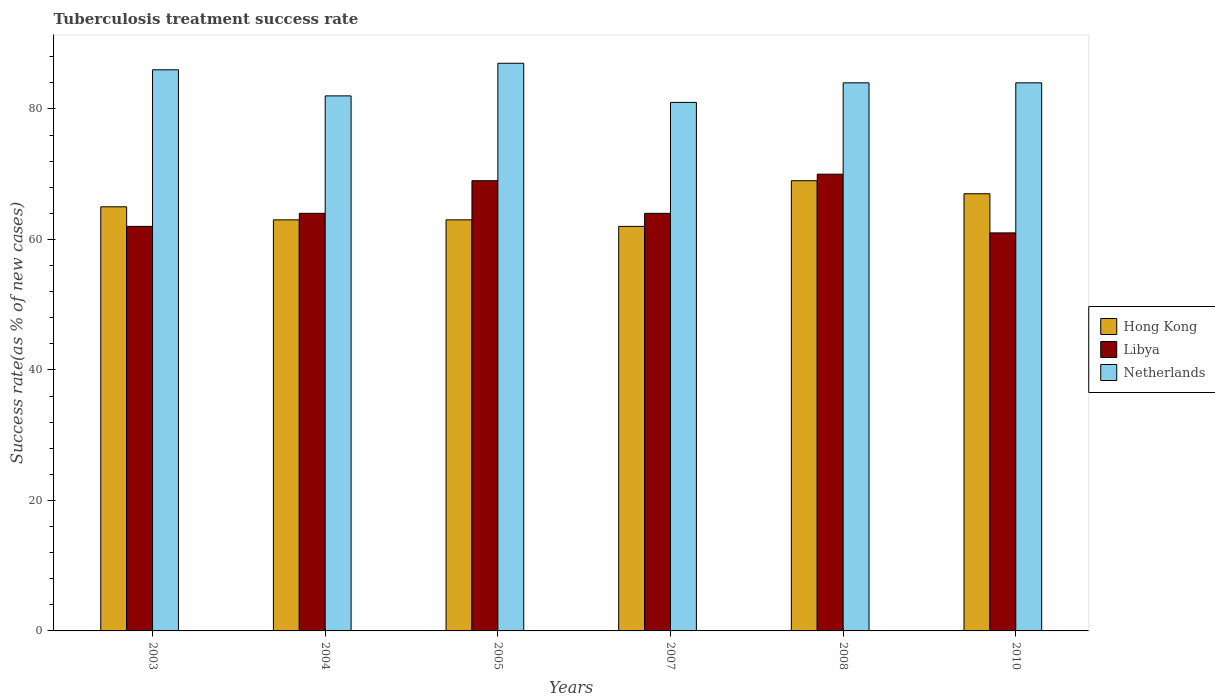How many different coloured bars are there?
Your response must be concise. 3. Are the number of bars on each tick of the X-axis equal?
Ensure brevity in your answer.  Yes. How many bars are there on the 4th tick from the left?
Offer a very short reply. 3. How many bars are there on the 3rd tick from the right?
Make the answer very short. 3. In how many cases, is the number of bars for a given year not equal to the number of legend labels?
Give a very brief answer. 0. Across all years, what is the minimum tuberculosis treatment success rate in Hong Kong?
Your answer should be very brief. 62. In which year was the tuberculosis treatment success rate in Hong Kong maximum?
Ensure brevity in your answer.  2008. In which year was the tuberculosis treatment success rate in Hong Kong minimum?
Offer a terse response. 2007. What is the total tuberculosis treatment success rate in Netherlands in the graph?
Your answer should be very brief. 504. What is the difference between the tuberculosis treatment success rate in Libya in 2005 and that in 2010?
Ensure brevity in your answer.  8. What is the average tuberculosis treatment success rate in Libya per year?
Offer a very short reply. 65. In the year 2008, what is the difference between the tuberculosis treatment success rate in Hong Kong and tuberculosis treatment success rate in Libya?
Ensure brevity in your answer.  -1. What is the ratio of the tuberculosis treatment success rate in Hong Kong in 2003 to that in 2007?
Keep it short and to the point. 1.05. Is the difference between the tuberculosis treatment success rate in Hong Kong in 2003 and 2004 greater than the difference between the tuberculosis treatment success rate in Libya in 2003 and 2004?
Ensure brevity in your answer.  Yes. What is the difference between the highest and the lowest tuberculosis treatment success rate in Hong Kong?
Provide a succinct answer. 7. Is the sum of the tuberculosis treatment success rate in Libya in 2003 and 2005 greater than the maximum tuberculosis treatment success rate in Netherlands across all years?
Provide a short and direct response. Yes. What does the 3rd bar from the left in 2007 represents?
Keep it short and to the point. Netherlands. What does the 1st bar from the right in 2007 represents?
Provide a succinct answer. Netherlands. Is it the case that in every year, the sum of the tuberculosis treatment success rate in Hong Kong and tuberculosis treatment success rate in Netherlands is greater than the tuberculosis treatment success rate in Libya?
Keep it short and to the point. Yes. Does the graph contain any zero values?
Provide a succinct answer. No. Does the graph contain grids?
Your response must be concise. No. What is the title of the graph?
Your answer should be very brief. Tuberculosis treatment success rate. Does "Oman" appear as one of the legend labels in the graph?
Offer a terse response. No. What is the label or title of the Y-axis?
Give a very brief answer. Success rate(as % of new cases). What is the Success rate(as % of new cases) of Hong Kong in 2003?
Give a very brief answer. 65. What is the Success rate(as % of new cases) of Netherlands in 2003?
Provide a succinct answer. 86. What is the Success rate(as % of new cases) in Hong Kong in 2004?
Give a very brief answer. 63. What is the Success rate(as % of new cases) in Hong Kong in 2005?
Your answer should be compact. 63. What is the Success rate(as % of new cases) of Libya in 2005?
Make the answer very short. 69. What is the Success rate(as % of new cases) in Netherlands in 2005?
Offer a terse response. 87. What is the Success rate(as % of new cases) of Hong Kong in 2007?
Your answer should be compact. 62. What is the Success rate(as % of new cases) of Netherlands in 2007?
Offer a very short reply. 81. What is the Success rate(as % of new cases) of Hong Kong in 2008?
Keep it short and to the point. 69. What is the Success rate(as % of new cases) of Libya in 2008?
Your answer should be compact. 70. What is the Success rate(as % of new cases) in Netherlands in 2008?
Ensure brevity in your answer.  84. What is the Success rate(as % of new cases) in Hong Kong in 2010?
Provide a succinct answer. 67. What is the Success rate(as % of new cases) of Libya in 2010?
Provide a succinct answer. 61. Across all years, what is the maximum Success rate(as % of new cases) in Hong Kong?
Provide a succinct answer. 69. Across all years, what is the minimum Success rate(as % of new cases) in Libya?
Your response must be concise. 61. What is the total Success rate(as % of new cases) of Hong Kong in the graph?
Keep it short and to the point. 389. What is the total Success rate(as % of new cases) in Libya in the graph?
Give a very brief answer. 390. What is the total Success rate(as % of new cases) in Netherlands in the graph?
Your answer should be compact. 504. What is the difference between the Success rate(as % of new cases) of Hong Kong in 2003 and that in 2004?
Provide a succinct answer. 2. What is the difference between the Success rate(as % of new cases) of Hong Kong in 2003 and that in 2007?
Your response must be concise. 3. What is the difference between the Success rate(as % of new cases) of Netherlands in 2003 and that in 2007?
Provide a short and direct response. 5. What is the difference between the Success rate(as % of new cases) in Hong Kong in 2003 and that in 2008?
Offer a very short reply. -4. What is the difference between the Success rate(as % of new cases) of Netherlands in 2003 and that in 2008?
Your answer should be very brief. 2. What is the difference between the Success rate(as % of new cases) of Libya in 2003 and that in 2010?
Offer a terse response. 1. What is the difference between the Success rate(as % of new cases) of Libya in 2004 and that in 2005?
Offer a terse response. -5. What is the difference between the Success rate(as % of new cases) of Libya in 2004 and that in 2007?
Your answer should be compact. 0. What is the difference between the Success rate(as % of new cases) of Netherlands in 2004 and that in 2007?
Provide a short and direct response. 1. What is the difference between the Success rate(as % of new cases) of Hong Kong in 2004 and that in 2008?
Your answer should be very brief. -6. What is the difference between the Success rate(as % of new cases) of Libya in 2004 and that in 2008?
Provide a succinct answer. -6. What is the difference between the Success rate(as % of new cases) in Netherlands in 2004 and that in 2008?
Provide a short and direct response. -2. What is the difference between the Success rate(as % of new cases) of Hong Kong in 2004 and that in 2010?
Provide a short and direct response. -4. What is the difference between the Success rate(as % of new cases) of Libya in 2004 and that in 2010?
Your answer should be very brief. 3. What is the difference between the Success rate(as % of new cases) of Libya in 2005 and that in 2007?
Provide a succinct answer. 5. What is the difference between the Success rate(as % of new cases) of Libya in 2005 and that in 2008?
Provide a short and direct response. -1. What is the difference between the Success rate(as % of new cases) of Libya in 2005 and that in 2010?
Give a very brief answer. 8. What is the difference between the Success rate(as % of new cases) in Netherlands in 2005 and that in 2010?
Keep it short and to the point. 3. What is the difference between the Success rate(as % of new cases) of Hong Kong in 2007 and that in 2008?
Offer a very short reply. -7. What is the difference between the Success rate(as % of new cases) of Libya in 2007 and that in 2008?
Keep it short and to the point. -6. What is the difference between the Success rate(as % of new cases) in Hong Kong in 2007 and that in 2010?
Make the answer very short. -5. What is the difference between the Success rate(as % of new cases) of Netherlands in 2007 and that in 2010?
Offer a very short reply. -3. What is the difference between the Success rate(as % of new cases) of Hong Kong in 2008 and that in 2010?
Offer a terse response. 2. What is the difference between the Success rate(as % of new cases) of Libya in 2008 and that in 2010?
Provide a succinct answer. 9. What is the difference between the Success rate(as % of new cases) in Hong Kong in 2003 and the Success rate(as % of new cases) in Libya in 2004?
Keep it short and to the point. 1. What is the difference between the Success rate(as % of new cases) of Libya in 2003 and the Success rate(as % of new cases) of Netherlands in 2004?
Ensure brevity in your answer.  -20. What is the difference between the Success rate(as % of new cases) in Hong Kong in 2003 and the Success rate(as % of new cases) in Libya in 2005?
Your answer should be very brief. -4. What is the difference between the Success rate(as % of new cases) in Hong Kong in 2003 and the Success rate(as % of new cases) in Netherlands in 2005?
Offer a very short reply. -22. What is the difference between the Success rate(as % of new cases) of Libya in 2003 and the Success rate(as % of new cases) of Netherlands in 2007?
Your answer should be compact. -19. What is the difference between the Success rate(as % of new cases) of Hong Kong in 2003 and the Success rate(as % of new cases) of Libya in 2008?
Provide a succinct answer. -5. What is the difference between the Success rate(as % of new cases) in Hong Kong in 2003 and the Success rate(as % of new cases) in Netherlands in 2008?
Your answer should be very brief. -19. What is the difference between the Success rate(as % of new cases) in Hong Kong in 2003 and the Success rate(as % of new cases) in Netherlands in 2010?
Keep it short and to the point. -19. What is the difference between the Success rate(as % of new cases) in Libya in 2004 and the Success rate(as % of new cases) in Netherlands in 2005?
Provide a short and direct response. -23. What is the difference between the Success rate(as % of new cases) in Libya in 2004 and the Success rate(as % of new cases) in Netherlands in 2007?
Provide a succinct answer. -17. What is the difference between the Success rate(as % of new cases) in Hong Kong in 2004 and the Success rate(as % of new cases) in Libya in 2008?
Offer a very short reply. -7. What is the difference between the Success rate(as % of new cases) of Hong Kong in 2004 and the Success rate(as % of new cases) of Netherlands in 2008?
Your answer should be compact. -21. What is the difference between the Success rate(as % of new cases) of Libya in 2004 and the Success rate(as % of new cases) of Netherlands in 2010?
Give a very brief answer. -20. What is the difference between the Success rate(as % of new cases) in Hong Kong in 2005 and the Success rate(as % of new cases) in Libya in 2007?
Make the answer very short. -1. What is the difference between the Success rate(as % of new cases) of Hong Kong in 2005 and the Success rate(as % of new cases) of Netherlands in 2007?
Make the answer very short. -18. What is the difference between the Success rate(as % of new cases) in Libya in 2005 and the Success rate(as % of new cases) in Netherlands in 2007?
Provide a succinct answer. -12. What is the difference between the Success rate(as % of new cases) in Hong Kong in 2005 and the Success rate(as % of new cases) in Libya in 2010?
Your response must be concise. 2. What is the difference between the Success rate(as % of new cases) of Hong Kong in 2005 and the Success rate(as % of new cases) of Netherlands in 2010?
Your response must be concise. -21. What is the difference between the Success rate(as % of new cases) in Libya in 2005 and the Success rate(as % of new cases) in Netherlands in 2010?
Your answer should be very brief. -15. What is the difference between the Success rate(as % of new cases) in Hong Kong in 2007 and the Success rate(as % of new cases) in Netherlands in 2008?
Provide a succinct answer. -22. What is the difference between the Success rate(as % of new cases) of Hong Kong in 2007 and the Success rate(as % of new cases) of Libya in 2010?
Your response must be concise. 1. What is the difference between the Success rate(as % of new cases) in Libya in 2007 and the Success rate(as % of new cases) in Netherlands in 2010?
Ensure brevity in your answer.  -20. What is the difference between the Success rate(as % of new cases) of Hong Kong in 2008 and the Success rate(as % of new cases) of Netherlands in 2010?
Make the answer very short. -15. What is the average Success rate(as % of new cases) of Hong Kong per year?
Your answer should be very brief. 64.83. What is the average Success rate(as % of new cases) of Libya per year?
Give a very brief answer. 65. In the year 2003, what is the difference between the Success rate(as % of new cases) in Hong Kong and Success rate(as % of new cases) in Libya?
Provide a succinct answer. 3. In the year 2003, what is the difference between the Success rate(as % of new cases) of Hong Kong and Success rate(as % of new cases) of Netherlands?
Your answer should be very brief. -21. In the year 2003, what is the difference between the Success rate(as % of new cases) of Libya and Success rate(as % of new cases) of Netherlands?
Make the answer very short. -24. In the year 2004, what is the difference between the Success rate(as % of new cases) in Hong Kong and Success rate(as % of new cases) in Netherlands?
Give a very brief answer. -19. In the year 2004, what is the difference between the Success rate(as % of new cases) in Libya and Success rate(as % of new cases) in Netherlands?
Make the answer very short. -18. In the year 2005, what is the difference between the Success rate(as % of new cases) of Hong Kong and Success rate(as % of new cases) of Libya?
Provide a short and direct response. -6. In the year 2007, what is the difference between the Success rate(as % of new cases) of Hong Kong and Success rate(as % of new cases) of Netherlands?
Provide a short and direct response. -19. In the year 2008, what is the difference between the Success rate(as % of new cases) in Hong Kong and Success rate(as % of new cases) in Netherlands?
Offer a terse response. -15. In the year 2010, what is the difference between the Success rate(as % of new cases) of Libya and Success rate(as % of new cases) of Netherlands?
Make the answer very short. -23. What is the ratio of the Success rate(as % of new cases) of Hong Kong in 2003 to that in 2004?
Make the answer very short. 1.03. What is the ratio of the Success rate(as % of new cases) of Libya in 2003 to that in 2004?
Offer a terse response. 0.97. What is the ratio of the Success rate(as % of new cases) of Netherlands in 2003 to that in 2004?
Your answer should be very brief. 1.05. What is the ratio of the Success rate(as % of new cases) in Hong Kong in 2003 to that in 2005?
Give a very brief answer. 1.03. What is the ratio of the Success rate(as % of new cases) of Libya in 2003 to that in 2005?
Ensure brevity in your answer.  0.9. What is the ratio of the Success rate(as % of new cases) in Hong Kong in 2003 to that in 2007?
Keep it short and to the point. 1.05. What is the ratio of the Success rate(as % of new cases) in Libya in 2003 to that in 2007?
Make the answer very short. 0.97. What is the ratio of the Success rate(as % of new cases) of Netherlands in 2003 to that in 2007?
Ensure brevity in your answer.  1.06. What is the ratio of the Success rate(as % of new cases) in Hong Kong in 2003 to that in 2008?
Ensure brevity in your answer.  0.94. What is the ratio of the Success rate(as % of new cases) of Libya in 2003 to that in 2008?
Ensure brevity in your answer.  0.89. What is the ratio of the Success rate(as % of new cases) in Netherlands in 2003 to that in 2008?
Give a very brief answer. 1.02. What is the ratio of the Success rate(as % of new cases) in Hong Kong in 2003 to that in 2010?
Provide a short and direct response. 0.97. What is the ratio of the Success rate(as % of new cases) in Libya in 2003 to that in 2010?
Your answer should be very brief. 1.02. What is the ratio of the Success rate(as % of new cases) of Netherlands in 2003 to that in 2010?
Offer a terse response. 1.02. What is the ratio of the Success rate(as % of new cases) of Libya in 2004 to that in 2005?
Offer a terse response. 0.93. What is the ratio of the Success rate(as % of new cases) in Netherlands in 2004 to that in 2005?
Give a very brief answer. 0.94. What is the ratio of the Success rate(as % of new cases) in Hong Kong in 2004 to that in 2007?
Give a very brief answer. 1.02. What is the ratio of the Success rate(as % of new cases) in Libya in 2004 to that in 2007?
Provide a succinct answer. 1. What is the ratio of the Success rate(as % of new cases) in Netherlands in 2004 to that in 2007?
Your response must be concise. 1.01. What is the ratio of the Success rate(as % of new cases) of Hong Kong in 2004 to that in 2008?
Provide a short and direct response. 0.91. What is the ratio of the Success rate(as % of new cases) of Libya in 2004 to that in 2008?
Offer a terse response. 0.91. What is the ratio of the Success rate(as % of new cases) of Netherlands in 2004 to that in 2008?
Keep it short and to the point. 0.98. What is the ratio of the Success rate(as % of new cases) of Hong Kong in 2004 to that in 2010?
Your answer should be compact. 0.94. What is the ratio of the Success rate(as % of new cases) of Libya in 2004 to that in 2010?
Provide a succinct answer. 1.05. What is the ratio of the Success rate(as % of new cases) of Netherlands in 2004 to that in 2010?
Offer a terse response. 0.98. What is the ratio of the Success rate(as % of new cases) in Hong Kong in 2005 to that in 2007?
Make the answer very short. 1.02. What is the ratio of the Success rate(as % of new cases) in Libya in 2005 to that in 2007?
Your response must be concise. 1.08. What is the ratio of the Success rate(as % of new cases) in Netherlands in 2005 to that in 2007?
Provide a succinct answer. 1.07. What is the ratio of the Success rate(as % of new cases) of Libya in 2005 to that in 2008?
Keep it short and to the point. 0.99. What is the ratio of the Success rate(as % of new cases) in Netherlands in 2005 to that in 2008?
Provide a short and direct response. 1.04. What is the ratio of the Success rate(as % of new cases) of Hong Kong in 2005 to that in 2010?
Offer a terse response. 0.94. What is the ratio of the Success rate(as % of new cases) of Libya in 2005 to that in 2010?
Your response must be concise. 1.13. What is the ratio of the Success rate(as % of new cases) in Netherlands in 2005 to that in 2010?
Give a very brief answer. 1.04. What is the ratio of the Success rate(as % of new cases) of Hong Kong in 2007 to that in 2008?
Provide a short and direct response. 0.9. What is the ratio of the Success rate(as % of new cases) in Libya in 2007 to that in 2008?
Keep it short and to the point. 0.91. What is the ratio of the Success rate(as % of new cases) of Hong Kong in 2007 to that in 2010?
Your response must be concise. 0.93. What is the ratio of the Success rate(as % of new cases) of Libya in 2007 to that in 2010?
Provide a succinct answer. 1.05. What is the ratio of the Success rate(as % of new cases) in Netherlands in 2007 to that in 2010?
Your response must be concise. 0.96. What is the ratio of the Success rate(as % of new cases) of Hong Kong in 2008 to that in 2010?
Provide a short and direct response. 1.03. What is the ratio of the Success rate(as % of new cases) of Libya in 2008 to that in 2010?
Provide a short and direct response. 1.15. What is the difference between the highest and the second highest Success rate(as % of new cases) in Netherlands?
Offer a terse response. 1. What is the difference between the highest and the lowest Success rate(as % of new cases) of Hong Kong?
Offer a very short reply. 7. What is the difference between the highest and the lowest Success rate(as % of new cases) of Libya?
Give a very brief answer. 9. What is the difference between the highest and the lowest Success rate(as % of new cases) in Netherlands?
Give a very brief answer. 6. 